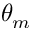Convert formula to latex. <formula><loc_0><loc_0><loc_500><loc_500>\theta _ { m }</formula> 